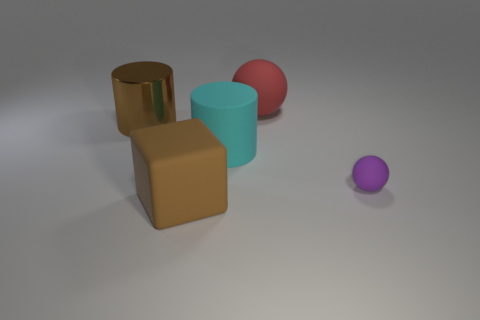What shape is the rubber thing that is the same color as the large metallic cylinder?
Your response must be concise. Cube. There is a big brown thing that is behind the small purple rubber sphere; does it have the same shape as the large cyan thing?
Provide a succinct answer. Yes. How many things are both in front of the small purple rubber thing and behind the big brown cylinder?
Your answer should be very brief. 0. How many other large objects are the same shape as the brown matte thing?
Ensure brevity in your answer.  0. The big thing in front of the sphere that is to the right of the large matte sphere is what color?
Provide a short and direct response. Brown. Do the large red matte thing and the thing on the right side of the large red matte sphere have the same shape?
Ensure brevity in your answer.  Yes. What material is the brown thing behind the tiny purple rubber object that is to the right of the brown object that is in front of the big cyan cylinder made of?
Offer a very short reply. Metal. Is there another brown thing that has the same size as the brown matte thing?
Your answer should be compact. Yes. The purple ball that is the same material as the large cube is what size?
Your response must be concise. Small. The tiny purple matte thing is what shape?
Offer a very short reply. Sphere. 